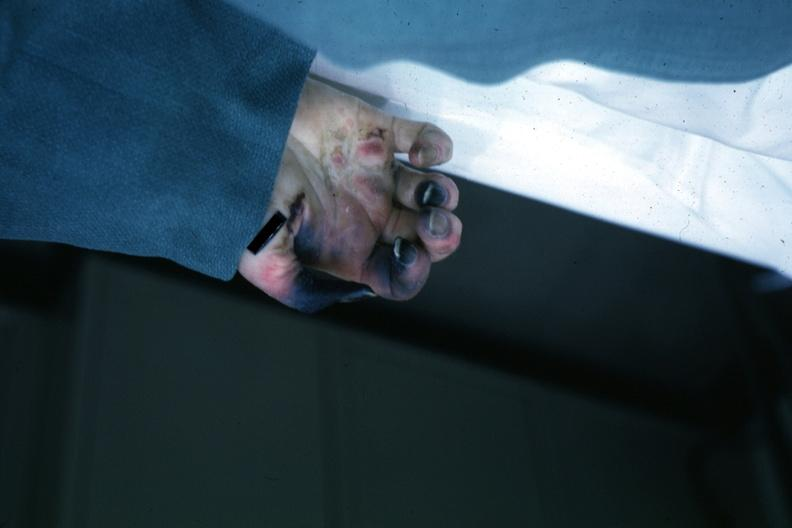why does this image show obvious gangrenous necrosis?
Answer the question using a single word or phrase. Due to shock or embolism postoperative cardiac surgery 